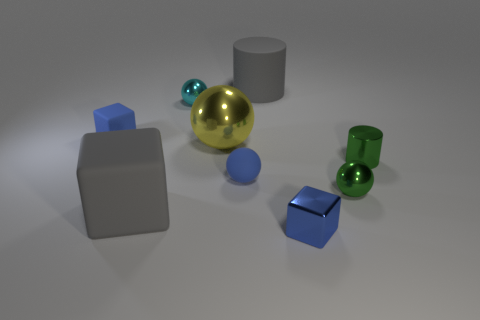What number of tiny matte objects have the same shape as the blue metallic thing?
Make the answer very short. 1. Is there a tiny cube of the same color as the rubber ball?
Your answer should be very brief. Yes. What number of things are either big objects that are in front of the metallic cylinder or metal things that are in front of the tiny cyan thing?
Keep it short and to the point. 5. There is a green object to the right of the green metallic sphere; are there any small blue spheres that are to the right of it?
Your answer should be very brief. No. The rubber thing that is the same size as the blue matte sphere is what shape?
Offer a very short reply. Cube. How many things are either small blue shiny things that are in front of the yellow thing or small blue rubber spheres?
Offer a very short reply. 2. How many other things are made of the same material as the gray cube?
Provide a short and direct response. 3. What shape is the matte thing that is the same color as the tiny matte ball?
Make the answer very short. Cube. What size is the blue cube to the right of the matte cylinder?
Your response must be concise. Small. What shape is the gray object that is the same material as the big cylinder?
Keep it short and to the point. Cube. 